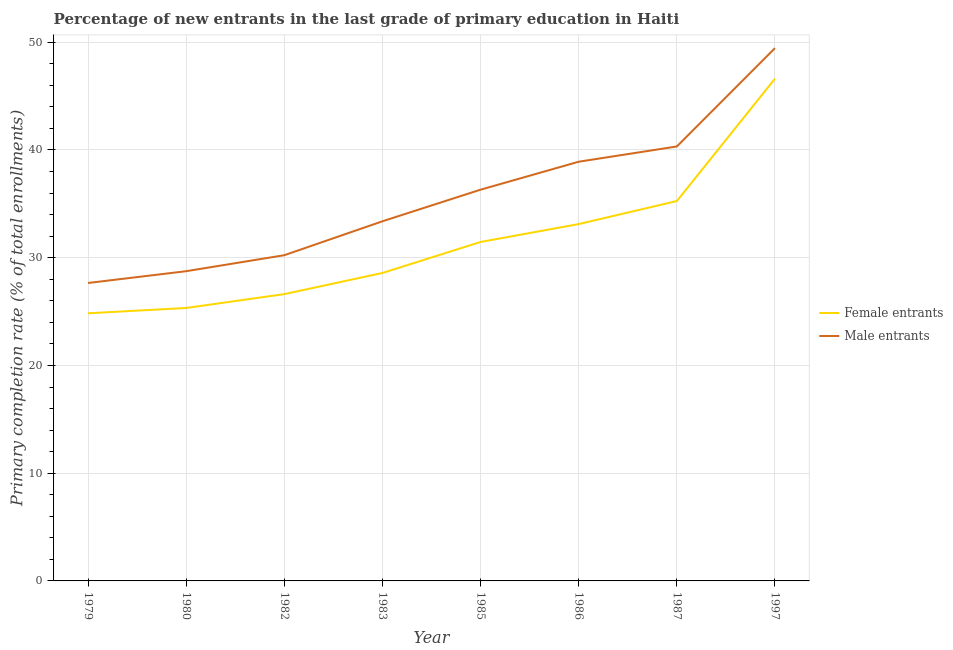Does the line corresponding to primary completion rate of female entrants intersect with the line corresponding to primary completion rate of male entrants?
Offer a very short reply. No. What is the primary completion rate of female entrants in 1987?
Provide a succinct answer. 35.26. Across all years, what is the maximum primary completion rate of female entrants?
Provide a succinct answer. 46.62. Across all years, what is the minimum primary completion rate of female entrants?
Provide a short and direct response. 24.84. In which year was the primary completion rate of female entrants minimum?
Your answer should be very brief. 1979. What is the total primary completion rate of female entrants in the graph?
Give a very brief answer. 251.85. What is the difference between the primary completion rate of female entrants in 1986 and that in 1987?
Your answer should be very brief. -2.14. What is the difference between the primary completion rate of female entrants in 1980 and the primary completion rate of male entrants in 1982?
Ensure brevity in your answer.  -4.9. What is the average primary completion rate of male entrants per year?
Your answer should be very brief. 35.63. In the year 1987, what is the difference between the primary completion rate of male entrants and primary completion rate of female entrants?
Provide a succinct answer. 5.07. In how many years, is the primary completion rate of male entrants greater than 32 %?
Your answer should be compact. 5. What is the ratio of the primary completion rate of female entrants in 1979 to that in 1985?
Give a very brief answer. 0.79. Is the primary completion rate of female entrants in 1979 less than that in 1985?
Your response must be concise. Yes. What is the difference between the highest and the second highest primary completion rate of male entrants?
Your answer should be very brief. 9.13. What is the difference between the highest and the lowest primary completion rate of male entrants?
Provide a succinct answer. 21.8. In how many years, is the primary completion rate of male entrants greater than the average primary completion rate of male entrants taken over all years?
Your response must be concise. 4. Is the primary completion rate of female entrants strictly greater than the primary completion rate of male entrants over the years?
Offer a terse response. No. Is the primary completion rate of male entrants strictly less than the primary completion rate of female entrants over the years?
Ensure brevity in your answer.  No. What is the difference between two consecutive major ticks on the Y-axis?
Your answer should be very brief. 10. Are the values on the major ticks of Y-axis written in scientific E-notation?
Your answer should be very brief. No. Does the graph contain any zero values?
Offer a very short reply. No. Does the graph contain grids?
Give a very brief answer. Yes. Where does the legend appear in the graph?
Keep it short and to the point. Center right. How many legend labels are there?
Offer a terse response. 2. What is the title of the graph?
Ensure brevity in your answer.  Percentage of new entrants in the last grade of primary education in Haiti. Does "Malaria" appear as one of the legend labels in the graph?
Offer a terse response. No. What is the label or title of the Y-axis?
Your answer should be very brief. Primary completion rate (% of total enrollments). What is the Primary completion rate (% of total enrollments) in Female entrants in 1979?
Your answer should be very brief. 24.84. What is the Primary completion rate (% of total enrollments) of Male entrants in 1979?
Provide a short and direct response. 27.66. What is the Primary completion rate (% of total enrollments) in Female entrants in 1980?
Provide a short and direct response. 25.34. What is the Primary completion rate (% of total enrollments) of Male entrants in 1980?
Your answer should be very brief. 28.75. What is the Primary completion rate (% of total enrollments) of Female entrants in 1982?
Offer a very short reply. 26.62. What is the Primary completion rate (% of total enrollments) of Male entrants in 1982?
Provide a succinct answer. 30.23. What is the Primary completion rate (% of total enrollments) in Female entrants in 1983?
Provide a short and direct response. 28.58. What is the Primary completion rate (% of total enrollments) in Male entrants in 1983?
Offer a very short reply. 33.38. What is the Primary completion rate (% of total enrollments) of Female entrants in 1985?
Ensure brevity in your answer.  31.46. What is the Primary completion rate (% of total enrollments) of Male entrants in 1985?
Provide a succinct answer. 36.32. What is the Primary completion rate (% of total enrollments) of Female entrants in 1986?
Ensure brevity in your answer.  33.12. What is the Primary completion rate (% of total enrollments) of Male entrants in 1986?
Provide a succinct answer. 38.91. What is the Primary completion rate (% of total enrollments) in Female entrants in 1987?
Give a very brief answer. 35.26. What is the Primary completion rate (% of total enrollments) in Male entrants in 1987?
Offer a very short reply. 40.33. What is the Primary completion rate (% of total enrollments) of Female entrants in 1997?
Your answer should be very brief. 46.62. What is the Primary completion rate (% of total enrollments) in Male entrants in 1997?
Provide a short and direct response. 49.46. Across all years, what is the maximum Primary completion rate (% of total enrollments) of Female entrants?
Your answer should be very brief. 46.62. Across all years, what is the maximum Primary completion rate (% of total enrollments) in Male entrants?
Provide a succinct answer. 49.46. Across all years, what is the minimum Primary completion rate (% of total enrollments) of Female entrants?
Keep it short and to the point. 24.84. Across all years, what is the minimum Primary completion rate (% of total enrollments) in Male entrants?
Your response must be concise. 27.66. What is the total Primary completion rate (% of total enrollments) of Female entrants in the graph?
Your response must be concise. 251.85. What is the total Primary completion rate (% of total enrollments) in Male entrants in the graph?
Give a very brief answer. 285.04. What is the difference between the Primary completion rate (% of total enrollments) of Female entrants in 1979 and that in 1980?
Give a very brief answer. -0.49. What is the difference between the Primary completion rate (% of total enrollments) of Male entrants in 1979 and that in 1980?
Provide a short and direct response. -1.1. What is the difference between the Primary completion rate (% of total enrollments) of Female entrants in 1979 and that in 1982?
Your answer should be compact. -1.78. What is the difference between the Primary completion rate (% of total enrollments) of Male entrants in 1979 and that in 1982?
Provide a short and direct response. -2.58. What is the difference between the Primary completion rate (% of total enrollments) of Female entrants in 1979 and that in 1983?
Your response must be concise. -3.74. What is the difference between the Primary completion rate (% of total enrollments) of Male entrants in 1979 and that in 1983?
Offer a terse response. -5.73. What is the difference between the Primary completion rate (% of total enrollments) of Female entrants in 1979 and that in 1985?
Your response must be concise. -6.62. What is the difference between the Primary completion rate (% of total enrollments) of Male entrants in 1979 and that in 1985?
Keep it short and to the point. -8.66. What is the difference between the Primary completion rate (% of total enrollments) of Female entrants in 1979 and that in 1986?
Offer a terse response. -8.28. What is the difference between the Primary completion rate (% of total enrollments) of Male entrants in 1979 and that in 1986?
Your answer should be compact. -11.26. What is the difference between the Primary completion rate (% of total enrollments) in Female entrants in 1979 and that in 1987?
Your answer should be very brief. -10.42. What is the difference between the Primary completion rate (% of total enrollments) in Male entrants in 1979 and that in 1987?
Your answer should be very brief. -12.67. What is the difference between the Primary completion rate (% of total enrollments) of Female entrants in 1979 and that in 1997?
Offer a terse response. -21.78. What is the difference between the Primary completion rate (% of total enrollments) in Male entrants in 1979 and that in 1997?
Keep it short and to the point. -21.8. What is the difference between the Primary completion rate (% of total enrollments) in Female entrants in 1980 and that in 1982?
Your response must be concise. -1.29. What is the difference between the Primary completion rate (% of total enrollments) in Male entrants in 1980 and that in 1982?
Offer a terse response. -1.48. What is the difference between the Primary completion rate (% of total enrollments) of Female entrants in 1980 and that in 1983?
Ensure brevity in your answer.  -3.25. What is the difference between the Primary completion rate (% of total enrollments) in Male entrants in 1980 and that in 1983?
Keep it short and to the point. -4.63. What is the difference between the Primary completion rate (% of total enrollments) of Female entrants in 1980 and that in 1985?
Your answer should be very brief. -6.13. What is the difference between the Primary completion rate (% of total enrollments) of Male entrants in 1980 and that in 1985?
Make the answer very short. -7.57. What is the difference between the Primary completion rate (% of total enrollments) of Female entrants in 1980 and that in 1986?
Provide a succinct answer. -7.79. What is the difference between the Primary completion rate (% of total enrollments) in Male entrants in 1980 and that in 1986?
Ensure brevity in your answer.  -10.16. What is the difference between the Primary completion rate (% of total enrollments) in Female entrants in 1980 and that in 1987?
Your answer should be compact. -9.92. What is the difference between the Primary completion rate (% of total enrollments) in Male entrants in 1980 and that in 1987?
Your answer should be compact. -11.58. What is the difference between the Primary completion rate (% of total enrollments) of Female entrants in 1980 and that in 1997?
Ensure brevity in your answer.  -21.28. What is the difference between the Primary completion rate (% of total enrollments) of Male entrants in 1980 and that in 1997?
Your answer should be compact. -20.71. What is the difference between the Primary completion rate (% of total enrollments) in Female entrants in 1982 and that in 1983?
Provide a succinct answer. -1.96. What is the difference between the Primary completion rate (% of total enrollments) in Male entrants in 1982 and that in 1983?
Offer a terse response. -3.15. What is the difference between the Primary completion rate (% of total enrollments) in Female entrants in 1982 and that in 1985?
Your answer should be very brief. -4.84. What is the difference between the Primary completion rate (% of total enrollments) of Male entrants in 1982 and that in 1985?
Keep it short and to the point. -6.08. What is the difference between the Primary completion rate (% of total enrollments) of Female entrants in 1982 and that in 1986?
Make the answer very short. -6.5. What is the difference between the Primary completion rate (% of total enrollments) in Male entrants in 1982 and that in 1986?
Your answer should be very brief. -8.68. What is the difference between the Primary completion rate (% of total enrollments) in Female entrants in 1982 and that in 1987?
Your answer should be very brief. -8.64. What is the difference between the Primary completion rate (% of total enrollments) of Male entrants in 1982 and that in 1987?
Your answer should be very brief. -10.09. What is the difference between the Primary completion rate (% of total enrollments) in Female entrants in 1982 and that in 1997?
Provide a short and direct response. -20. What is the difference between the Primary completion rate (% of total enrollments) in Male entrants in 1982 and that in 1997?
Your answer should be very brief. -19.22. What is the difference between the Primary completion rate (% of total enrollments) in Female entrants in 1983 and that in 1985?
Offer a very short reply. -2.88. What is the difference between the Primary completion rate (% of total enrollments) in Male entrants in 1983 and that in 1985?
Provide a succinct answer. -2.93. What is the difference between the Primary completion rate (% of total enrollments) of Female entrants in 1983 and that in 1986?
Your response must be concise. -4.54. What is the difference between the Primary completion rate (% of total enrollments) in Male entrants in 1983 and that in 1986?
Make the answer very short. -5.53. What is the difference between the Primary completion rate (% of total enrollments) in Female entrants in 1983 and that in 1987?
Offer a terse response. -6.67. What is the difference between the Primary completion rate (% of total enrollments) in Male entrants in 1983 and that in 1987?
Offer a terse response. -6.94. What is the difference between the Primary completion rate (% of total enrollments) in Female entrants in 1983 and that in 1997?
Your answer should be compact. -18.04. What is the difference between the Primary completion rate (% of total enrollments) in Male entrants in 1983 and that in 1997?
Offer a terse response. -16.07. What is the difference between the Primary completion rate (% of total enrollments) in Female entrants in 1985 and that in 1986?
Keep it short and to the point. -1.66. What is the difference between the Primary completion rate (% of total enrollments) in Male entrants in 1985 and that in 1986?
Provide a short and direct response. -2.59. What is the difference between the Primary completion rate (% of total enrollments) of Female entrants in 1985 and that in 1987?
Your response must be concise. -3.8. What is the difference between the Primary completion rate (% of total enrollments) in Male entrants in 1985 and that in 1987?
Keep it short and to the point. -4.01. What is the difference between the Primary completion rate (% of total enrollments) in Female entrants in 1985 and that in 1997?
Give a very brief answer. -15.16. What is the difference between the Primary completion rate (% of total enrollments) in Male entrants in 1985 and that in 1997?
Your answer should be compact. -13.14. What is the difference between the Primary completion rate (% of total enrollments) in Female entrants in 1986 and that in 1987?
Provide a short and direct response. -2.14. What is the difference between the Primary completion rate (% of total enrollments) in Male entrants in 1986 and that in 1987?
Keep it short and to the point. -1.42. What is the difference between the Primary completion rate (% of total enrollments) in Female entrants in 1986 and that in 1997?
Your answer should be very brief. -13.5. What is the difference between the Primary completion rate (% of total enrollments) in Male entrants in 1986 and that in 1997?
Ensure brevity in your answer.  -10.54. What is the difference between the Primary completion rate (% of total enrollments) of Female entrants in 1987 and that in 1997?
Keep it short and to the point. -11.36. What is the difference between the Primary completion rate (% of total enrollments) in Male entrants in 1987 and that in 1997?
Make the answer very short. -9.13. What is the difference between the Primary completion rate (% of total enrollments) of Female entrants in 1979 and the Primary completion rate (% of total enrollments) of Male entrants in 1980?
Provide a succinct answer. -3.91. What is the difference between the Primary completion rate (% of total enrollments) in Female entrants in 1979 and the Primary completion rate (% of total enrollments) in Male entrants in 1982?
Provide a short and direct response. -5.39. What is the difference between the Primary completion rate (% of total enrollments) of Female entrants in 1979 and the Primary completion rate (% of total enrollments) of Male entrants in 1983?
Your answer should be very brief. -8.54. What is the difference between the Primary completion rate (% of total enrollments) in Female entrants in 1979 and the Primary completion rate (% of total enrollments) in Male entrants in 1985?
Your response must be concise. -11.47. What is the difference between the Primary completion rate (% of total enrollments) of Female entrants in 1979 and the Primary completion rate (% of total enrollments) of Male entrants in 1986?
Provide a short and direct response. -14.07. What is the difference between the Primary completion rate (% of total enrollments) in Female entrants in 1979 and the Primary completion rate (% of total enrollments) in Male entrants in 1987?
Provide a short and direct response. -15.49. What is the difference between the Primary completion rate (% of total enrollments) in Female entrants in 1979 and the Primary completion rate (% of total enrollments) in Male entrants in 1997?
Offer a very short reply. -24.61. What is the difference between the Primary completion rate (% of total enrollments) in Female entrants in 1980 and the Primary completion rate (% of total enrollments) in Male entrants in 1982?
Your answer should be compact. -4.9. What is the difference between the Primary completion rate (% of total enrollments) in Female entrants in 1980 and the Primary completion rate (% of total enrollments) in Male entrants in 1983?
Ensure brevity in your answer.  -8.05. What is the difference between the Primary completion rate (% of total enrollments) in Female entrants in 1980 and the Primary completion rate (% of total enrollments) in Male entrants in 1985?
Ensure brevity in your answer.  -10.98. What is the difference between the Primary completion rate (% of total enrollments) of Female entrants in 1980 and the Primary completion rate (% of total enrollments) of Male entrants in 1986?
Ensure brevity in your answer.  -13.58. What is the difference between the Primary completion rate (% of total enrollments) of Female entrants in 1980 and the Primary completion rate (% of total enrollments) of Male entrants in 1987?
Give a very brief answer. -14.99. What is the difference between the Primary completion rate (% of total enrollments) in Female entrants in 1980 and the Primary completion rate (% of total enrollments) in Male entrants in 1997?
Offer a terse response. -24.12. What is the difference between the Primary completion rate (% of total enrollments) of Female entrants in 1982 and the Primary completion rate (% of total enrollments) of Male entrants in 1983?
Your response must be concise. -6.76. What is the difference between the Primary completion rate (% of total enrollments) in Female entrants in 1982 and the Primary completion rate (% of total enrollments) in Male entrants in 1985?
Provide a short and direct response. -9.69. What is the difference between the Primary completion rate (% of total enrollments) of Female entrants in 1982 and the Primary completion rate (% of total enrollments) of Male entrants in 1986?
Your answer should be compact. -12.29. What is the difference between the Primary completion rate (% of total enrollments) of Female entrants in 1982 and the Primary completion rate (% of total enrollments) of Male entrants in 1987?
Provide a succinct answer. -13.71. What is the difference between the Primary completion rate (% of total enrollments) of Female entrants in 1982 and the Primary completion rate (% of total enrollments) of Male entrants in 1997?
Provide a short and direct response. -22.83. What is the difference between the Primary completion rate (% of total enrollments) of Female entrants in 1983 and the Primary completion rate (% of total enrollments) of Male entrants in 1985?
Make the answer very short. -7.73. What is the difference between the Primary completion rate (% of total enrollments) in Female entrants in 1983 and the Primary completion rate (% of total enrollments) in Male entrants in 1986?
Ensure brevity in your answer.  -10.33. What is the difference between the Primary completion rate (% of total enrollments) in Female entrants in 1983 and the Primary completion rate (% of total enrollments) in Male entrants in 1987?
Ensure brevity in your answer.  -11.74. What is the difference between the Primary completion rate (% of total enrollments) of Female entrants in 1983 and the Primary completion rate (% of total enrollments) of Male entrants in 1997?
Provide a succinct answer. -20.87. What is the difference between the Primary completion rate (% of total enrollments) of Female entrants in 1985 and the Primary completion rate (% of total enrollments) of Male entrants in 1986?
Your response must be concise. -7.45. What is the difference between the Primary completion rate (% of total enrollments) in Female entrants in 1985 and the Primary completion rate (% of total enrollments) in Male entrants in 1987?
Your answer should be compact. -8.87. What is the difference between the Primary completion rate (% of total enrollments) of Female entrants in 1985 and the Primary completion rate (% of total enrollments) of Male entrants in 1997?
Offer a very short reply. -17.99. What is the difference between the Primary completion rate (% of total enrollments) of Female entrants in 1986 and the Primary completion rate (% of total enrollments) of Male entrants in 1987?
Your response must be concise. -7.2. What is the difference between the Primary completion rate (% of total enrollments) of Female entrants in 1986 and the Primary completion rate (% of total enrollments) of Male entrants in 1997?
Your answer should be very brief. -16.33. What is the difference between the Primary completion rate (% of total enrollments) in Female entrants in 1987 and the Primary completion rate (% of total enrollments) in Male entrants in 1997?
Your response must be concise. -14.2. What is the average Primary completion rate (% of total enrollments) of Female entrants per year?
Provide a succinct answer. 31.48. What is the average Primary completion rate (% of total enrollments) in Male entrants per year?
Ensure brevity in your answer.  35.63. In the year 1979, what is the difference between the Primary completion rate (% of total enrollments) in Female entrants and Primary completion rate (% of total enrollments) in Male entrants?
Provide a succinct answer. -2.81. In the year 1980, what is the difference between the Primary completion rate (% of total enrollments) in Female entrants and Primary completion rate (% of total enrollments) in Male entrants?
Your response must be concise. -3.41. In the year 1982, what is the difference between the Primary completion rate (% of total enrollments) of Female entrants and Primary completion rate (% of total enrollments) of Male entrants?
Your answer should be compact. -3.61. In the year 1983, what is the difference between the Primary completion rate (% of total enrollments) in Female entrants and Primary completion rate (% of total enrollments) in Male entrants?
Make the answer very short. -4.8. In the year 1985, what is the difference between the Primary completion rate (% of total enrollments) of Female entrants and Primary completion rate (% of total enrollments) of Male entrants?
Your answer should be compact. -4.85. In the year 1986, what is the difference between the Primary completion rate (% of total enrollments) of Female entrants and Primary completion rate (% of total enrollments) of Male entrants?
Ensure brevity in your answer.  -5.79. In the year 1987, what is the difference between the Primary completion rate (% of total enrollments) of Female entrants and Primary completion rate (% of total enrollments) of Male entrants?
Offer a very short reply. -5.07. In the year 1997, what is the difference between the Primary completion rate (% of total enrollments) of Female entrants and Primary completion rate (% of total enrollments) of Male entrants?
Your answer should be very brief. -2.84. What is the ratio of the Primary completion rate (% of total enrollments) of Female entrants in 1979 to that in 1980?
Your response must be concise. 0.98. What is the ratio of the Primary completion rate (% of total enrollments) in Male entrants in 1979 to that in 1980?
Keep it short and to the point. 0.96. What is the ratio of the Primary completion rate (% of total enrollments) in Female entrants in 1979 to that in 1982?
Your response must be concise. 0.93. What is the ratio of the Primary completion rate (% of total enrollments) in Male entrants in 1979 to that in 1982?
Ensure brevity in your answer.  0.91. What is the ratio of the Primary completion rate (% of total enrollments) of Female entrants in 1979 to that in 1983?
Your answer should be compact. 0.87. What is the ratio of the Primary completion rate (% of total enrollments) of Male entrants in 1979 to that in 1983?
Provide a short and direct response. 0.83. What is the ratio of the Primary completion rate (% of total enrollments) of Female entrants in 1979 to that in 1985?
Provide a short and direct response. 0.79. What is the ratio of the Primary completion rate (% of total enrollments) in Male entrants in 1979 to that in 1985?
Your answer should be compact. 0.76. What is the ratio of the Primary completion rate (% of total enrollments) of Female entrants in 1979 to that in 1986?
Provide a succinct answer. 0.75. What is the ratio of the Primary completion rate (% of total enrollments) in Male entrants in 1979 to that in 1986?
Keep it short and to the point. 0.71. What is the ratio of the Primary completion rate (% of total enrollments) of Female entrants in 1979 to that in 1987?
Offer a very short reply. 0.7. What is the ratio of the Primary completion rate (% of total enrollments) of Male entrants in 1979 to that in 1987?
Your answer should be very brief. 0.69. What is the ratio of the Primary completion rate (% of total enrollments) of Female entrants in 1979 to that in 1997?
Offer a very short reply. 0.53. What is the ratio of the Primary completion rate (% of total enrollments) of Male entrants in 1979 to that in 1997?
Your answer should be compact. 0.56. What is the ratio of the Primary completion rate (% of total enrollments) in Female entrants in 1980 to that in 1982?
Provide a succinct answer. 0.95. What is the ratio of the Primary completion rate (% of total enrollments) of Male entrants in 1980 to that in 1982?
Your answer should be very brief. 0.95. What is the ratio of the Primary completion rate (% of total enrollments) of Female entrants in 1980 to that in 1983?
Your answer should be compact. 0.89. What is the ratio of the Primary completion rate (% of total enrollments) in Male entrants in 1980 to that in 1983?
Offer a very short reply. 0.86. What is the ratio of the Primary completion rate (% of total enrollments) of Female entrants in 1980 to that in 1985?
Your response must be concise. 0.81. What is the ratio of the Primary completion rate (% of total enrollments) of Male entrants in 1980 to that in 1985?
Provide a succinct answer. 0.79. What is the ratio of the Primary completion rate (% of total enrollments) of Female entrants in 1980 to that in 1986?
Your answer should be compact. 0.76. What is the ratio of the Primary completion rate (% of total enrollments) in Male entrants in 1980 to that in 1986?
Offer a terse response. 0.74. What is the ratio of the Primary completion rate (% of total enrollments) in Female entrants in 1980 to that in 1987?
Provide a succinct answer. 0.72. What is the ratio of the Primary completion rate (% of total enrollments) of Male entrants in 1980 to that in 1987?
Provide a succinct answer. 0.71. What is the ratio of the Primary completion rate (% of total enrollments) in Female entrants in 1980 to that in 1997?
Provide a short and direct response. 0.54. What is the ratio of the Primary completion rate (% of total enrollments) in Male entrants in 1980 to that in 1997?
Keep it short and to the point. 0.58. What is the ratio of the Primary completion rate (% of total enrollments) in Female entrants in 1982 to that in 1983?
Provide a short and direct response. 0.93. What is the ratio of the Primary completion rate (% of total enrollments) in Male entrants in 1982 to that in 1983?
Give a very brief answer. 0.91. What is the ratio of the Primary completion rate (% of total enrollments) in Female entrants in 1982 to that in 1985?
Provide a succinct answer. 0.85. What is the ratio of the Primary completion rate (% of total enrollments) of Male entrants in 1982 to that in 1985?
Keep it short and to the point. 0.83. What is the ratio of the Primary completion rate (% of total enrollments) of Female entrants in 1982 to that in 1986?
Provide a short and direct response. 0.8. What is the ratio of the Primary completion rate (% of total enrollments) in Male entrants in 1982 to that in 1986?
Provide a succinct answer. 0.78. What is the ratio of the Primary completion rate (% of total enrollments) of Female entrants in 1982 to that in 1987?
Your answer should be very brief. 0.76. What is the ratio of the Primary completion rate (% of total enrollments) of Male entrants in 1982 to that in 1987?
Your response must be concise. 0.75. What is the ratio of the Primary completion rate (% of total enrollments) in Female entrants in 1982 to that in 1997?
Your response must be concise. 0.57. What is the ratio of the Primary completion rate (% of total enrollments) in Male entrants in 1982 to that in 1997?
Keep it short and to the point. 0.61. What is the ratio of the Primary completion rate (% of total enrollments) in Female entrants in 1983 to that in 1985?
Your answer should be very brief. 0.91. What is the ratio of the Primary completion rate (% of total enrollments) in Male entrants in 1983 to that in 1985?
Offer a very short reply. 0.92. What is the ratio of the Primary completion rate (% of total enrollments) of Female entrants in 1983 to that in 1986?
Give a very brief answer. 0.86. What is the ratio of the Primary completion rate (% of total enrollments) of Male entrants in 1983 to that in 1986?
Give a very brief answer. 0.86. What is the ratio of the Primary completion rate (% of total enrollments) of Female entrants in 1983 to that in 1987?
Make the answer very short. 0.81. What is the ratio of the Primary completion rate (% of total enrollments) in Male entrants in 1983 to that in 1987?
Keep it short and to the point. 0.83. What is the ratio of the Primary completion rate (% of total enrollments) of Female entrants in 1983 to that in 1997?
Your answer should be compact. 0.61. What is the ratio of the Primary completion rate (% of total enrollments) of Male entrants in 1983 to that in 1997?
Your answer should be very brief. 0.68. What is the ratio of the Primary completion rate (% of total enrollments) in Female entrants in 1985 to that in 1986?
Your answer should be very brief. 0.95. What is the ratio of the Primary completion rate (% of total enrollments) in Male entrants in 1985 to that in 1986?
Offer a terse response. 0.93. What is the ratio of the Primary completion rate (% of total enrollments) of Female entrants in 1985 to that in 1987?
Make the answer very short. 0.89. What is the ratio of the Primary completion rate (% of total enrollments) in Male entrants in 1985 to that in 1987?
Ensure brevity in your answer.  0.9. What is the ratio of the Primary completion rate (% of total enrollments) in Female entrants in 1985 to that in 1997?
Your response must be concise. 0.67. What is the ratio of the Primary completion rate (% of total enrollments) of Male entrants in 1985 to that in 1997?
Make the answer very short. 0.73. What is the ratio of the Primary completion rate (% of total enrollments) of Female entrants in 1986 to that in 1987?
Make the answer very short. 0.94. What is the ratio of the Primary completion rate (% of total enrollments) in Male entrants in 1986 to that in 1987?
Offer a very short reply. 0.96. What is the ratio of the Primary completion rate (% of total enrollments) in Female entrants in 1986 to that in 1997?
Make the answer very short. 0.71. What is the ratio of the Primary completion rate (% of total enrollments) of Male entrants in 1986 to that in 1997?
Offer a terse response. 0.79. What is the ratio of the Primary completion rate (% of total enrollments) in Female entrants in 1987 to that in 1997?
Make the answer very short. 0.76. What is the ratio of the Primary completion rate (% of total enrollments) of Male entrants in 1987 to that in 1997?
Offer a terse response. 0.82. What is the difference between the highest and the second highest Primary completion rate (% of total enrollments) in Female entrants?
Give a very brief answer. 11.36. What is the difference between the highest and the second highest Primary completion rate (% of total enrollments) in Male entrants?
Give a very brief answer. 9.13. What is the difference between the highest and the lowest Primary completion rate (% of total enrollments) in Female entrants?
Your answer should be very brief. 21.78. What is the difference between the highest and the lowest Primary completion rate (% of total enrollments) of Male entrants?
Offer a very short reply. 21.8. 